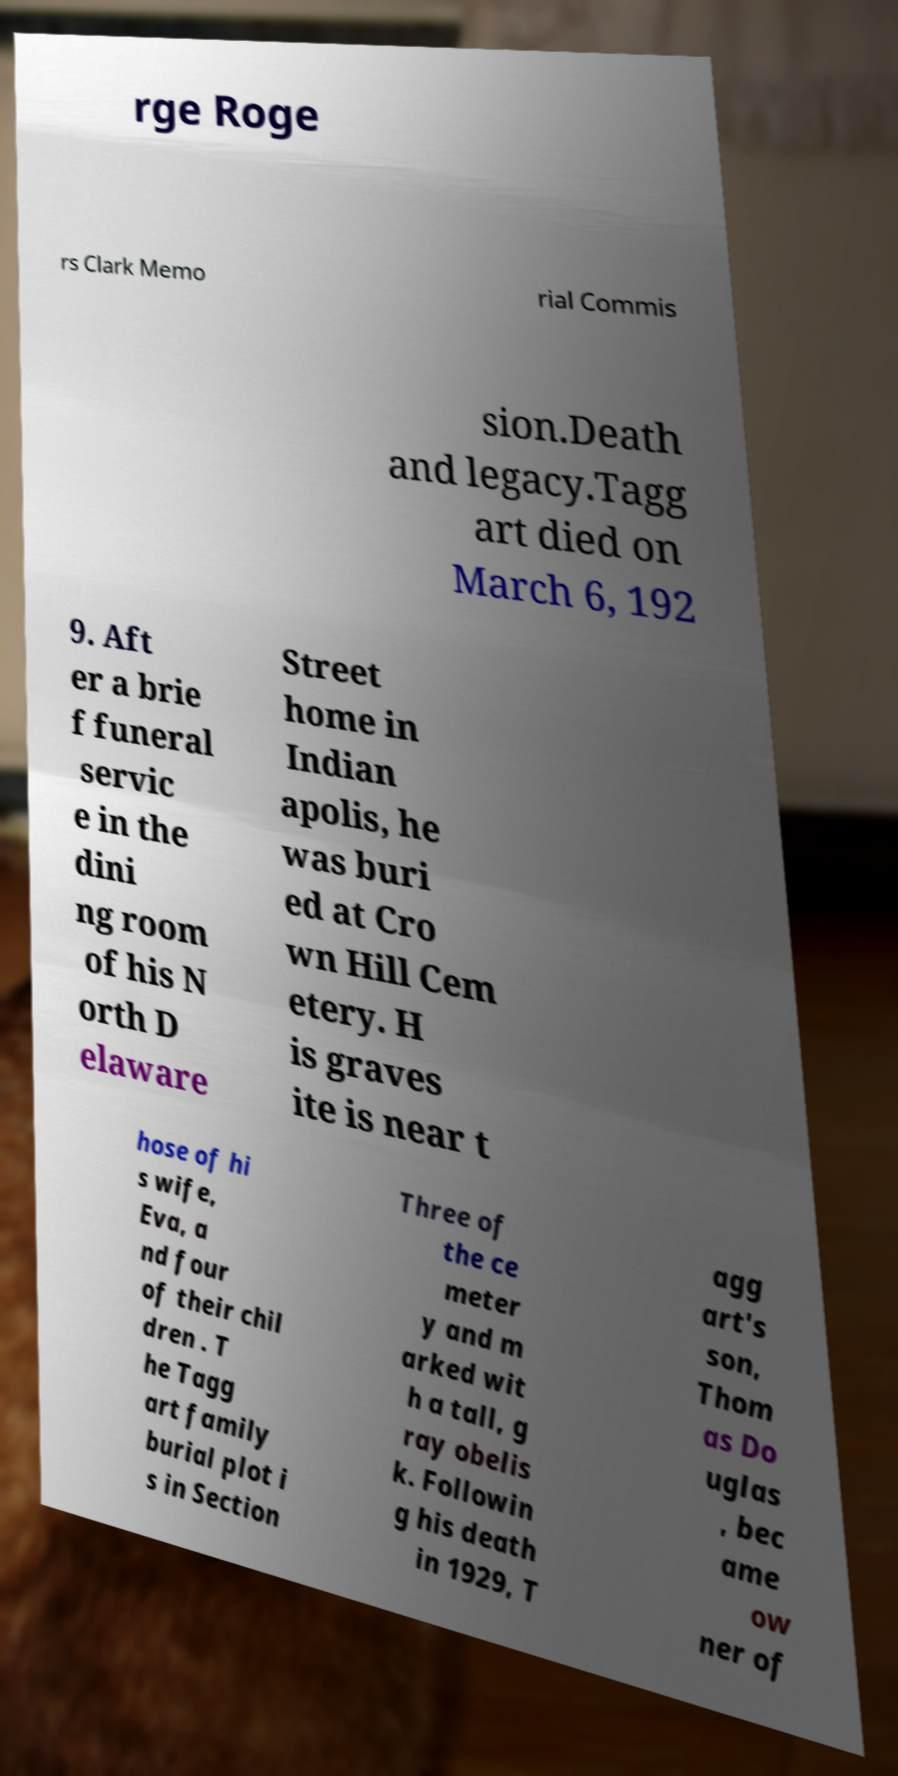I need the written content from this picture converted into text. Can you do that? rge Roge rs Clark Memo rial Commis sion.Death and legacy.Tagg art died on March 6, 192 9. Aft er a brie f funeral servic e in the dini ng room of his N orth D elaware Street home in Indian apolis, he was buri ed at Cro wn Hill Cem etery. H is graves ite is near t hose of hi s wife, Eva, a nd four of their chil dren . T he Tagg art family burial plot i s in Section Three of the ce meter y and m arked wit h a tall, g ray obelis k. Followin g his death in 1929, T agg art's son, Thom as Do uglas , bec ame ow ner of 